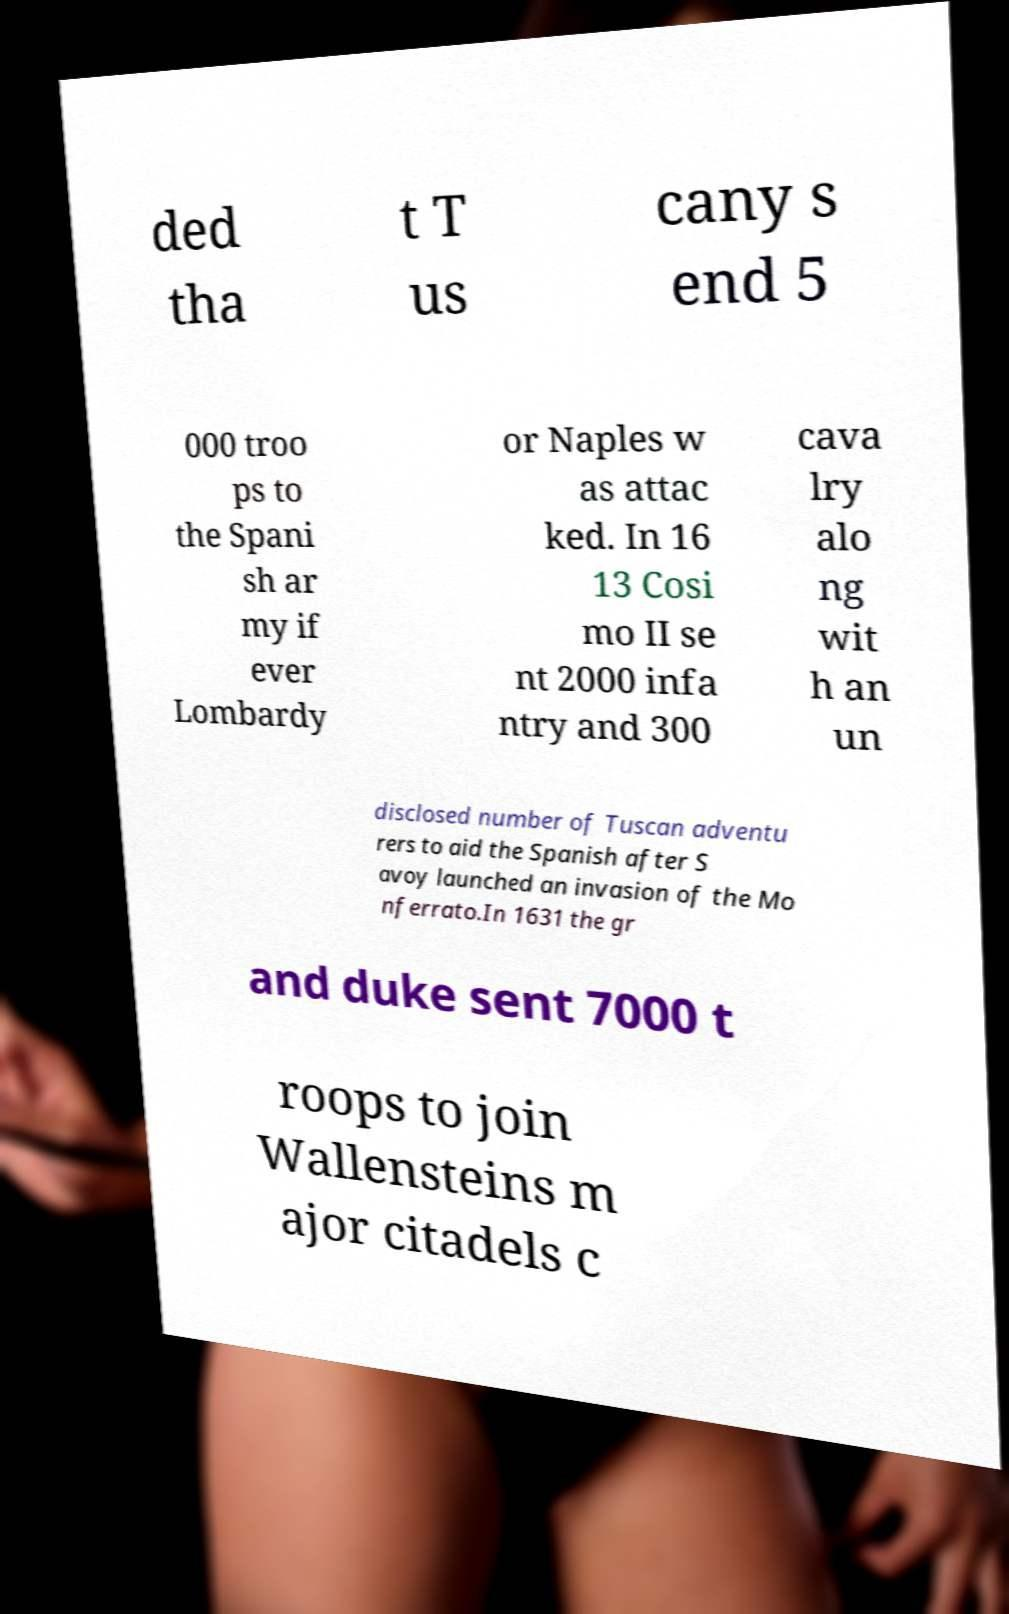Please read and relay the text visible in this image. What does it say? ded tha t T us cany s end 5 000 troo ps to the Spani sh ar my if ever Lombardy or Naples w as attac ked. In 16 13 Cosi mo II se nt 2000 infa ntry and 300 cava lry alo ng wit h an un disclosed number of Tuscan adventu rers to aid the Spanish after S avoy launched an invasion of the Mo nferrato.In 1631 the gr and duke sent 7000 t roops to join Wallensteins m ajor citadels c 